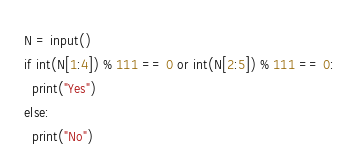Convert code to text. <code><loc_0><loc_0><loc_500><loc_500><_Python_>N = input()
if int(N[1:4]) % 111 == 0 or int(N[2:5]) % 111 == 0:
  print("Yes")
else:
  print("No")</code> 